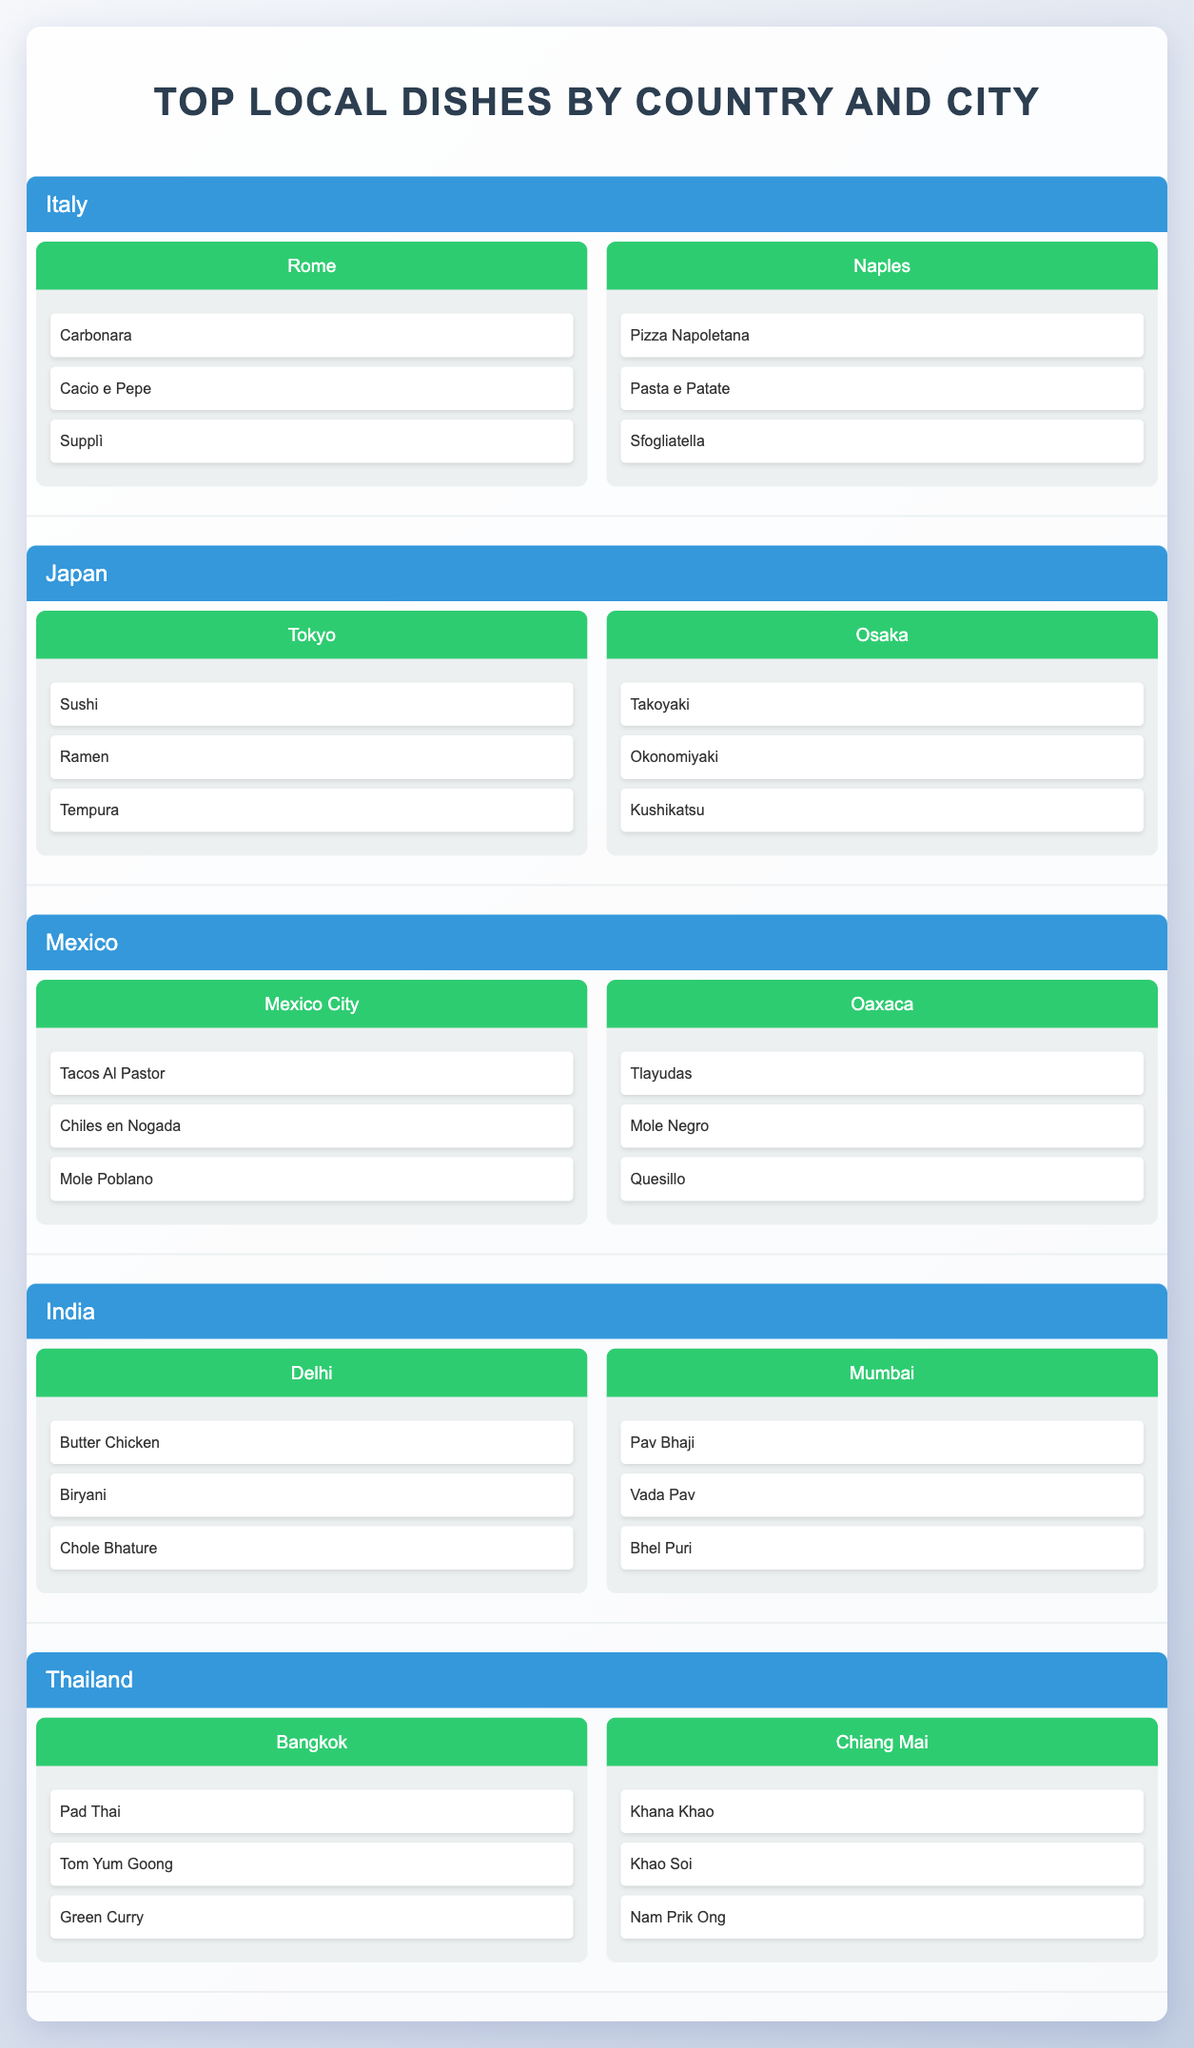What are the top local dishes in Tokyo? Referring to the table, Tokyo is associated with three dishes: Sushi, Ramen, and Tempura.
Answer: Sushi, Ramen, Tempura Does Naples have more local dishes than Osaka? Naples has three local dishes: Pizza Napoletana, Pasta e Patate, and Sfogliatella. Osaka also has three local dishes: Takoyaki, Okonomiyaki, and Kushikatsu. Therefore, they have the same number of dishes.
Answer: No Which city has Butter Chicken as a local dish? The city of Delhi is listed with Butter Chicken as one of its local dishes.
Answer: Delhi How many local dishes are there in total from both cities of Italy? Italy consists of Rome and Naples. Each city has three local dishes, resulting in a total of 3 (Rome) + 3 (Naples) = 6 dishes.
Answer: 6 Is it true that both Bangkok and Chiang Mai feature Pad Thai as a local dish? According to the table, Pad Thai is only listed under Bangkok, while Chiang Mai features different dishes (Khana Khao, Khao Soi, Nam Prik Ong). Therefore, this statement is false.
Answer: No Which country has the highest diversity of local dishes among its listed cities? To determine this, we must compare the number of dishes per country. Each country has cities with three dishes each. Italy, Japan, Mexico, India, and Thailand have cities with three dishes, giving a total of 3 dishes for each city in every country. Thus, all countries have the same dish diversity.
Answer: None What are the local dishes of Oaxaca? The city of Oaxaca is listed with three local dishes: Tlayudas, Mole Negro, and Quesillo.
Answer: Tlayudas, Mole Negro, Quesillo Which city has the dish known as Mole Poblano? Mole Poblano is associated with the city of Mexico City as per the table's listings.
Answer: Mexico City Count the number of distinct local dishes across all cities in Japan. Japan consists of Tokyo with three local dishes (Sushi, Ramen, Tempura) and Osaka with three local dishes (Takoyaki, Okonomiyaki, Kushikatsu). Therefore, the total distinct local dishes are 6 (3 from Tokyo + 3 from Osaka).
Answer: 6 